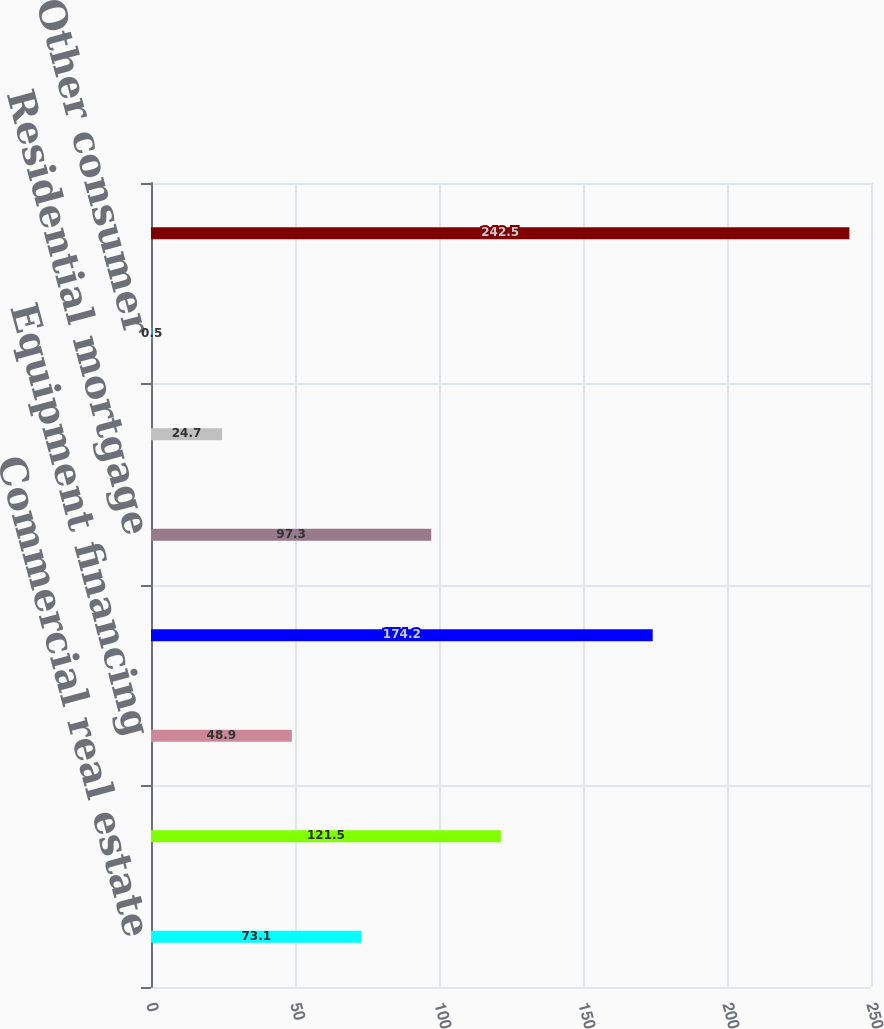<chart> <loc_0><loc_0><loc_500><loc_500><bar_chart><fcel>Commercial real estate<fcel>Commercial and industrial<fcel>Equipment financing<fcel>Total<fcel>Residential mortgage<fcel>Home equity<fcel>Other consumer<fcel>Total originated loans<nl><fcel>73.1<fcel>121.5<fcel>48.9<fcel>174.2<fcel>97.3<fcel>24.7<fcel>0.5<fcel>242.5<nl></chart> 